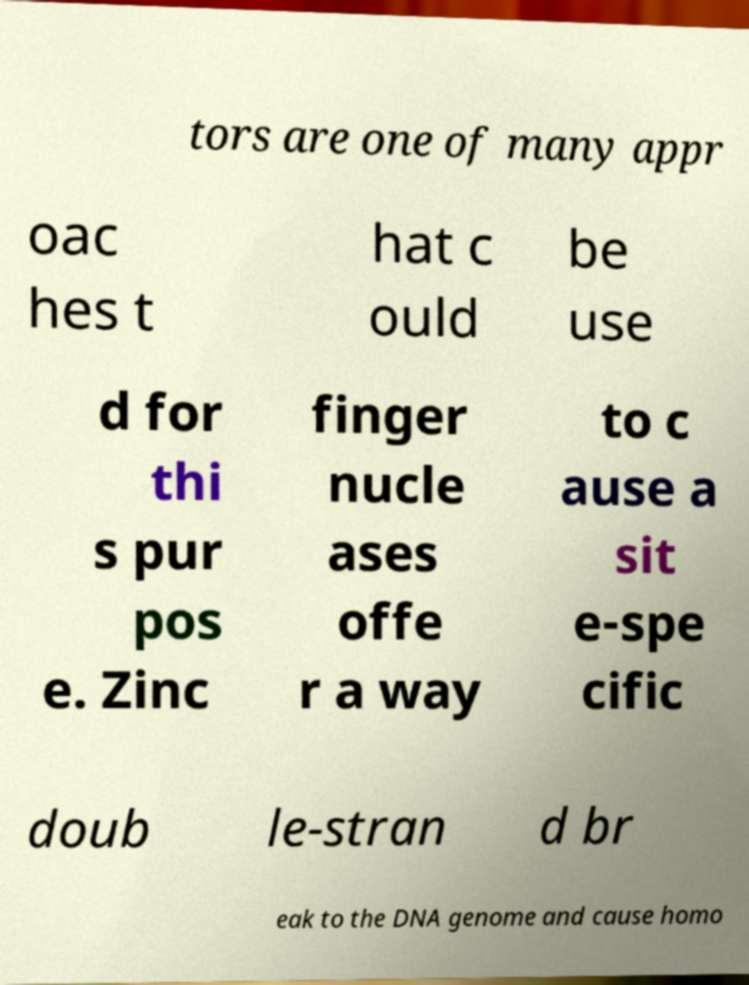For documentation purposes, I need the text within this image transcribed. Could you provide that? tors are one of many appr oac hes t hat c ould be use d for thi s pur pos e. Zinc finger nucle ases offe r a way to c ause a sit e-spe cific doub le-stran d br eak to the DNA genome and cause homo 